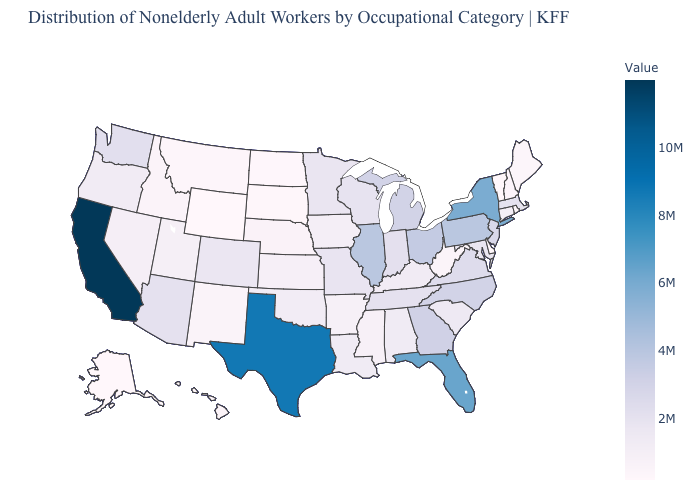Among the states that border Minnesota , which have the lowest value?
Keep it brief. North Dakota. Which states hav the highest value in the West?
Quick response, please. California. Does California have the highest value in the USA?
Answer briefly. Yes. Does Maine have the lowest value in the Northeast?
Concise answer only. No. 